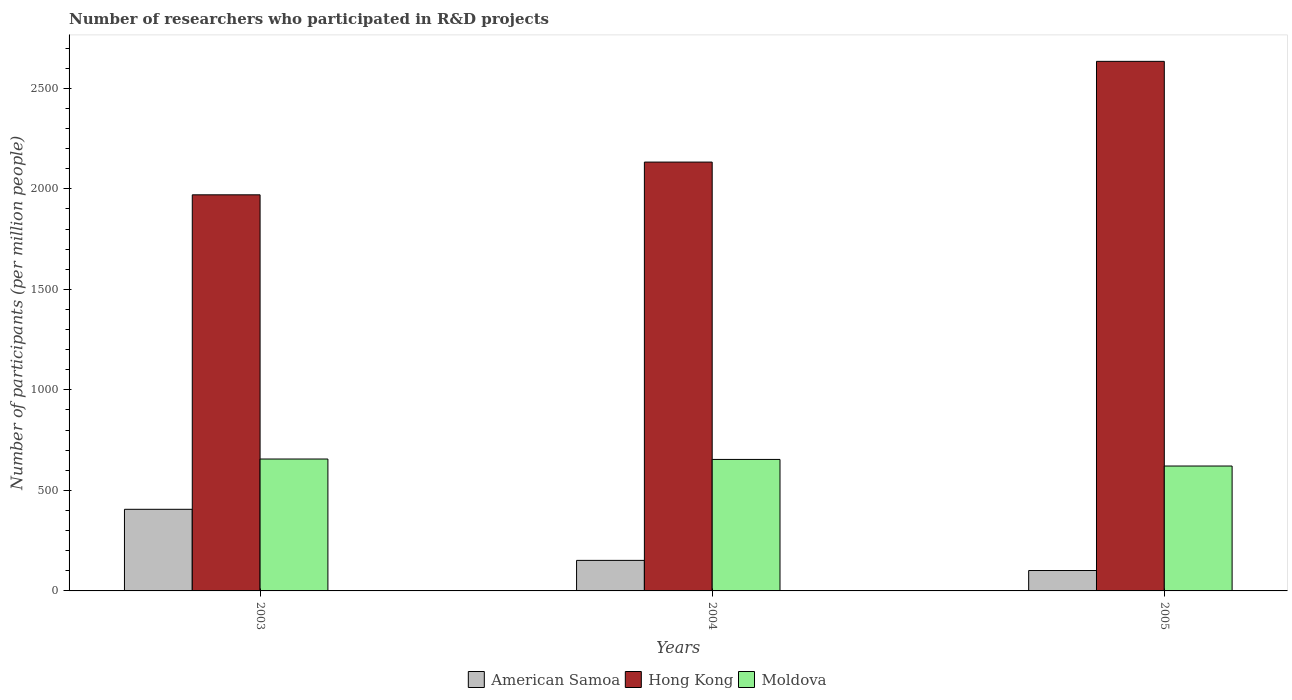How many different coloured bars are there?
Keep it short and to the point. 3. Are the number of bars per tick equal to the number of legend labels?
Offer a very short reply. Yes. How many bars are there on the 2nd tick from the left?
Make the answer very short. 3. What is the label of the 3rd group of bars from the left?
Ensure brevity in your answer.  2005. In how many cases, is the number of bars for a given year not equal to the number of legend labels?
Your response must be concise. 0. What is the number of researchers who participated in R&D projects in Hong Kong in 2005?
Provide a succinct answer. 2634.14. Across all years, what is the maximum number of researchers who participated in R&D projects in American Samoa?
Provide a succinct answer. 405.97. Across all years, what is the minimum number of researchers who participated in R&D projects in Moldova?
Offer a very short reply. 621.26. In which year was the number of researchers who participated in R&D projects in American Samoa maximum?
Make the answer very short. 2003. In which year was the number of researchers who participated in R&D projects in Moldova minimum?
Your answer should be very brief. 2005. What is the total number of researchers who participated in R&D projects in American Samoa in the graph?
Ensure brevity in your answer.  659.34. What is the difference between the number of researchers who participated in R&D projects in Hong Kong in 2004 and that in 2005?
Offer a terse response. -501.04. What is the difference between the number of researchers who participated in R&D projects in Moldova in 2005 and the number of researchers who participated in R&D projects in American Samoa in 2004?
Ensure brevity in your answer.  469.39. What is the average number of researchers who participated in R&D projects in Hong Kong per year?
Your answer should be compact. 2245.83. In the year 2005, what is the difference between the number of researchers who participated in R&D projects in Moldova and number of researchers who participated in R&D projects in Hong Kong?
Provide a succinct answer. -2012.88. What is the ratio of the number of researchers who participated in R&D projects in American Samoa in 2003 to that in 2004?
Your response must be concise. 2.67. Is the number of researchers who participated in R&D projects in American Samoa in 2003 less than that in 2004?
Your answer should be compact. No. What is the difference between the highest and the second highest number of researchers who participated in R&D projects in Hong Kong?
Keep it short and to the point. 501.04. What is the difference between the highest and the lowest number of researchers who participated in R&D projects in Hong Kong?
Provide a succinct answer. 663.88. What does the 2nd bar from the left in 2005 represents?
Give a very brief answer. Hong Kong. What does the 3rd bar from the right in 2005 represents?
Keep it short and to the point. American Samoa. Is it the case that in every year, the sum of the number of researchers who participated in R&D projects in American Samoa and number of researchers who participated in R&D projects in Moldova is greater than the number of researchers who participated in R&D projects in Hong Kong?
Your answer should be compact. No. How many bars are there?
Give a very brief answer. 9. What is the difference between two consecutive major ticks on the Y-axis?
Offer a terse response. 500. Does the graph contain grids?
Your answer should be compact. No. What is the title of the graph?
Your response must be concise. Number of researchers who participated in R&D projects. Does "Tunisia" appear as one of the legend labels in the graph?
Provide a short and direct response. No. What is the label or title of the Y-axis?
Ensure brevity in your answer.  Number of participants (per million people). What is the Number of participants (per million people) in American Samoa in 2003?
Provide a short and direct response. 405.97. What is the Number of participants (per million people) of Hong Kong in 2003?
Offer a very short reply. 1970.26. What is the Number of participants (per million people) in Moldova in 2003?
Ensure brevity in your answer.  656.09. What is the Number of participants (per million people) in American Samoa in 2004?
Provide a short and direct response. 151.87. What is the Number of participants (per million people) in Hong Kong in 2004?
Make the answer very short. 2133.09. What is the Number of participants (per million people) of Moldova in 2004?
Your answer should be very brief. 654.05. What is the Number of participants (per million people) in American Samoa in 2005?
Make the answer very short. 101.49. What is the Number of participants (per million people) of Hong Kong in 2005?
Ensure brevity in your answer.  2634.14. What is the Number of participants (per million people) of Moldova in 2005?
Your answer should be very brief. 621.26. Across all years, what is the maximum Number of participants (per million people) in American Samoa?
Your response must be concise. 405.97. Across all years, what is the maximum Number of participants (per million people) of Hong Kong?
Offer a very short reply. 2634.14. Across all years, what is the maximum Number of participants (per million people) in Moldova?
Ensure brevity in your answer.  656.09. Across all years, what is the minimum Number of participants (per million people) in American Samoa?
Your response must be concise. 101.49. Across all years, what is the minimum Number of participants (per million people) in Hong Kong?
Your response must be concise. 1970.26. Across all years, what is the minimum Number of participants (per million people) of Moldova?
Ensure brevity in your answer.  621.26. What is the total Number of participants (per million people) of American Samoa in the graph?
Your answer should be compact. 659.34. What is the total Number of participants (per million people) in Hong Kong in the graph?
Your answer should be compact. 6737.49. What is the total Number of participants (per million people) in Moldova in the graph?
Give a very brief answer. 1931.39. What is the difference between the Number of participants (per million people) in American Samoa in 2003 and that in 2004?
Your answer should be compact. 254.11. What is the difference between the Number of participants (per million people) of Hong Kong in 2003 and that in 2004?
Your answer should be very brief. -162.83. What is the difference between the Number of participants (per million people) in Moldova in 2003 and that in 2004?
Provide a short and direct response. 2.04. What is the difference between the Number of participants (per million people) in American Samoa in 2003 and that in 2005?
Keep it short and to the point. 304.48. What is the difference between the Number of participants (per million people) of Hong Kong in 2003 and that in 2005?
Keep it short and to the point. -663.88. What is the difference between the Number of participants (per million people) of Moldova in 2003 and that in 2005?
Your answer should be very brief. 34.83. What is the difference between the Number of participants (per million people) in American Samoa in 2004 and that in 2005?
Offer a terse response. 50.37. What is the difference between the Number of participants (per million people) of Hong Kong in 2004 and that in 2005?
Provide a short and direct response. -501.04. What is the difference between the Number of participants (per million people) in Moldova in 2004 and that in 2005?
Your answer should be compact. 32.79. What is the difference between the Number of participants (per million people) in American Samoa in 2003 and the Number of participants (per million people) in Hong Kong in 2004?
Make the answer very short. -1727.12. What is the difference between the Number of participants (per million people) of American Samoa in 2003 and the Number of participants (per million people) of Moldova in 2004?
Make the answer very short. -248.07. What is the difference between the Number of participants (per million people) of Hong Kong in 2003 and the Number of participants (per million people) of Moldova in 2004?
Provide a succinct answer. 1316.21. What is the difference between the Number of participants (per million people) in American Samoa in 2003 and the Number of participants (per million people) in Hong Kong in 2005?
Your answer should be compact. -2228.16. What is the difference between the Number of participants (per million people) of American Samoa in 2003 and the Number of participants (per million people) of Moldova in 2005?
Make the answer very short. -215.28. What is the difference between the Number of participants (per million people) in Hong Kong in 2003 and the Number of participants (per million people) in Moldova in 2005?
Keep it short and to the point. 1349.01. What is the difference between the Number of participants (per million people) in American Samoa in 2004 and the Number of participants (per million people) in Hong Kong in 2005?
Offer a terse response. -2482.27. What is the difference between the Number of participants (per million people) in American Samoa in 2004 and the Number of participants (per million people) in Moldova in 2005?
Offer a very short reply. -469.39. What is the difference between the Number of participants (per million people) of Hong Kong in 2004 and the Number of participants (per million people) of Moldova in 2005?
Offer a terse response. 1511.84. What is the average Number of participants (per million people) of American Samoa per year?
Keep it short and to the point. 219.78. What is the average Number of participants (per million people) in Hong Kong per year?
Your response must be concise. 2245.83. What is the average Number of participants (per million people) of Moldova per year?
Make the answer very short. 643.8. In the year 2003, what is the difference between the Number of participants (per million people) in American Samoa and Number of participants (per million people) in Hong Kong?
Your answer should be compact. -1564.29. In the year 2003, what is the difference between the Number of participants (per million people) in American Samoa and Number of participants (per million people) in Moldova?
Your answer should be compact. -250.12. In the year 2003, what is the difference between the Number of participants (per million people) of Hong Kong and Number of participants (per million people) of Moldova?
Your answer should be very brief. 1314.17. In the year 2004, what is the difference between the Number of participants (per million people) of American Samoa and Number of participants (per million people) of Hong Kong?
Your response must be concise. -1981.23. In the year 2004, what is the difference between the Number of participants (per million people) in American Samoa and Number of participants (per million people) in Moldova?
Offer a terse response. -502.18. In the year 2004, what is the difference between the Number of participants (per million people) of Hong Kong and Number of participants (per million people) of Moldova?
Offer a terse response. 1479.05. In the year 2005, what is the difference between the Number of participants (per million people) of American Samoa and Number of participants (per million people) of Hong Kong?
Your answer should be compact. -2532.64. In the year 2005, what is the difference between the Number of participants (per million people) in American Samoa and Number of participants (per million people) in Moldova?
Offer a very short reply. -519.76. In the year 2005, what is the difference between the Number of participants (per million people) in Hong Kong and Number of participants (per million people) in Moldova?
Your answer should be compact. 2012.88. What is the ratio of the Number of participants (per million people) of American Samoa in 2003 to that in 2004?
Give a very brief answer. 2.67. What is the ratio of the Number of participants (per million people) of Hong Kong in 2003 to that in 2004?
Ensure brevity in your answer.  0.92. What is the ratio of the Number of participants (per million people) in Moldova in 2003 to that in 2004?
Your answer should be very brief. 1. What is the ratio of the Number of participants (per million people) of American Samoa in 2003 to that in 2005?
Make the answer very short. 4. What is the ratio of the Number of participants (per million people) in Hong Kong in 2003 to that in 2005?
Provide a short and direct response. 0.75. What is the ratio of the Number of participants (per million people) in Moldova in 2003 to that in 2005?
Your response must be concise. 1.06. What is the ratio of the Number of participants (per million people) in American Samoa in 2004 to that in 2005?
Provide a succinct answer. 1.5. What is the ratio of the Number of participants (per million people) of Hong Kong in 2004 to that in 2005?
Keep it short and to the point. 0.81. What is the ratio of the Number of participants (per million people) in Moldova in 2004 to that in 2005?
Give a very brief answer. 1.05. What is the difference between the highest and the second highest Number of participants (per million people) of American Samoa?
Give a very brief answer. 254.11. What is the difference between the highest and the second highest Number of participants (per million people) in Hong Kong?
Offer a terse response. 501.04. What is the difference between the highest and the second highest Number of participants (per million people) in Moldova?
Give a very brief answer. 2.04. What is the difference between the highest and the lowest Number of participants (per million people) of American Samoa?
Give a very brief answer. 304.48. What is the difference between the highest and the lowest Number of participants (per million people) in Hong Kong?
Give a very brief answer. 663.88. What is the difference between the highest and the lowest Number of participants (per million people) in Moldova?
Keep it short and to the point. 34.83. 